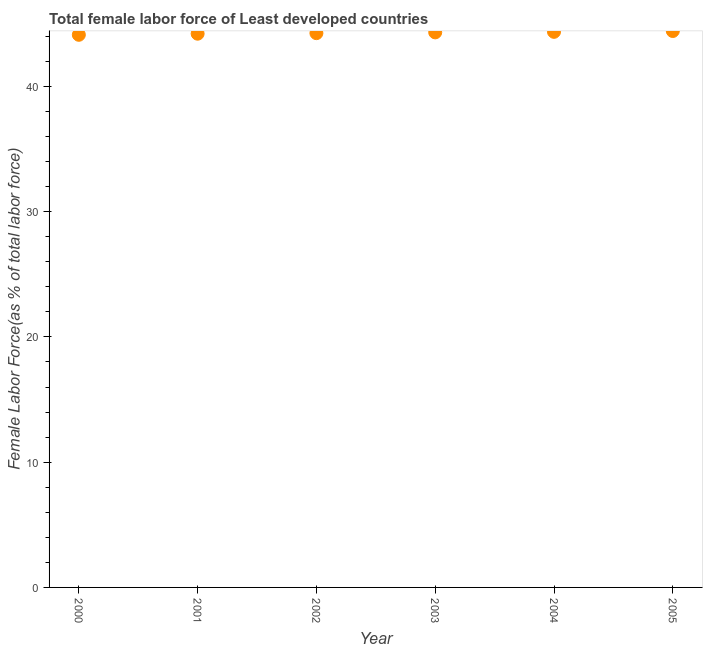What is the total female labor force in 2002?
Your answer should be very brief. 44.25. Across all years, what is the maximum total female labor force?
Give a very brief answer. 44.42. Across all years, what is the minimum total female labor force?
Ensure brevity in your answer.  44.12. What is the sum of the total female labor force?
Your answer should be compact. 265.66. What is the difference between the total female labor force in 2004 and 2005?
Ensure brevity in your answer.  -0.07. What is the average total female labor force per year?
Give a very brief answer. 44.28. What is the median total female labor force?
Offer a very short reply. 44.28. In how many years, is the total female labor force greater than 34 %?
Keep it short and to the point. 6. Do a majority of the years between 2005 and 2000 (inclusive) have total female labor force greater than 42 %?
Your answer should be very brief. Yes. What is the ratio of the total female labor force in 2004 to that in 2005?
Provide a succinct answer. 1. Is the difference between the total female labor force in 2001 and 2002 greater than the difference between any two years?
Provide a succinct answer. No. What is the difference between the highest and the second highest total female labor force?
Your answer should be compact. 0.07. Is the sum of the total female labor force in 2003 and 2005 greater than the maximum total female labor force across all years?
Your answer should be very brief. Yes. What is the difference between the highest and the lowest total female labor force?
Give a very brief answer. 0.3. In how many years, is the total female labor force greater than the average total female labor force taken over all years?
Ensure brevity in your answer.  3. Does the total female labor force monotonically increase over the years?
Your response must be concise. Yes. How many dotlines are there?
Offer a very short reply. 1. How many years are there in the graph?
Your answer should be compact. 6. What is the difference between two consecutive major ticks on the Y-axis?
Provide a short and direct response. 10. What is the title of the graph?
Offer a very short reply. Total female labor force of Least developed countries. What is the label or title of the Y-axis?
Provide a succinct answer. Female Labor Force(as % of total labor force). What is the Female Labor Force(as % of total labor force) in 2000?
Give a very brief answer. 44.12. What is the Female Labor Force(as % of total labor force) in 2001?
Give a very brief answer. 44.21. What is the Female Labor Force(as % of total labor force) in 2002?
Make the answer very short. 44.25. What is the Female Labor Force(as % of total labor force) in 2003?
Your response must be concise. 44.31. What is the Female Labor Force(as % of total labor force) in 2004?
Your answer should be compact. 44.35. What is the Female Labor Force(as % of total labor force) in 2005?
Provide a short and direct response. 44.42. What is the difference between the Female Labor Force(as % of total labor force) in 2000 and 2001?
Offer a terse response. -0.09. What is the difference between the Female Labor Force(as % of total labor force) in 2000 and 2002?
Ensure brevity in your answer.  -0.13. What is the difference between the Female Labor Force(as % of total labor force) in 2000 and 2003?
Your response must be concise. -0.19. What is the difference between the Female Labor Force(as % of total labor force) in 2000 and 2004?
Your answer should be compact. -0.24. What is the difference between the Female Labor Force(as % of total labor force) in 2000 and 2005?
Ensure brevity in your answer.  -0.3. What is the difference between the Female Labor Force(as % of total labor force) in 2001 and 2002?
Ensure brevity in your answer.  -0.04. What is the difference between the Female Labor Force(as % of total labor force) in 2001 and 2003?
Your answer should be very brief. -0.1. What is the difference between the Female Labor Force(as % of total labor force) in 2001 and 2004?
Your answer should be compact. -0.15. What is the difference between the Female Labor Force(as % of total labor force) in 2001 and 2005?
Your answer should be very brief. -0.21. What is the difference between the Female Labor Force(as % of total labor force) in 2002 and 2003?
Your response must be concise. -0.06. What is the difference between the Female Labor Force(as % of total labor force) in 2002 and 2004?
Provide a short and direct response. -0.1. What is the difference between the Female Labor Force(as % of total labor force) in 2002 and 2005?
Make the answer very short. -0.17. What is the difference between the Female Labor Force(as % of total labor force) in 2003 and 2004?
Your answer should be compact. -0.04. What is the difference between the Female Labor Force(as % of total labor force) in 2003 and 2005?
Your response must be concise. -0.11. What is the difference between the Female Labor Force(as % of total labor force) in 2004 and 2005?
Your response must be concise. -0.07. What is the ratio of the Female Labor Force(as % of total labor force) in 2000 to that in 2003?
Offer a terse response. 1. What is the ratio of the Female Labor Force(as % of total labor force) in 2000 to that in 2004?
Keep it short and to the point. 0.99. What is the ratio of the Female Labor Force(as % of total labor force) in 2001 to that in 2003?
Provide a succinct answer. 1. What is the ratio of the Female Labor Force(as % of total labor force) in 2001 to that in 2004?
Your answer should be very brief. 1. What is the ratio of the Female Labor Force(as % of total labor force) in 2002 to that in 2004?
Give a very brief answer. 1. What is the ratio of the Female Labor Force(as % of total labor force) in 2002 to that in 2005?
Offer a very short reply. 1. What is the ratio of the Female Labor Force(as % of total labor force) in 2003 to that in 2004?
Provide a succinct answer. 1. What is the ratio of the Female Labor Force(as % of total labor force) in 2004 to that in 2005?
Your answer should be very brief. 1. 